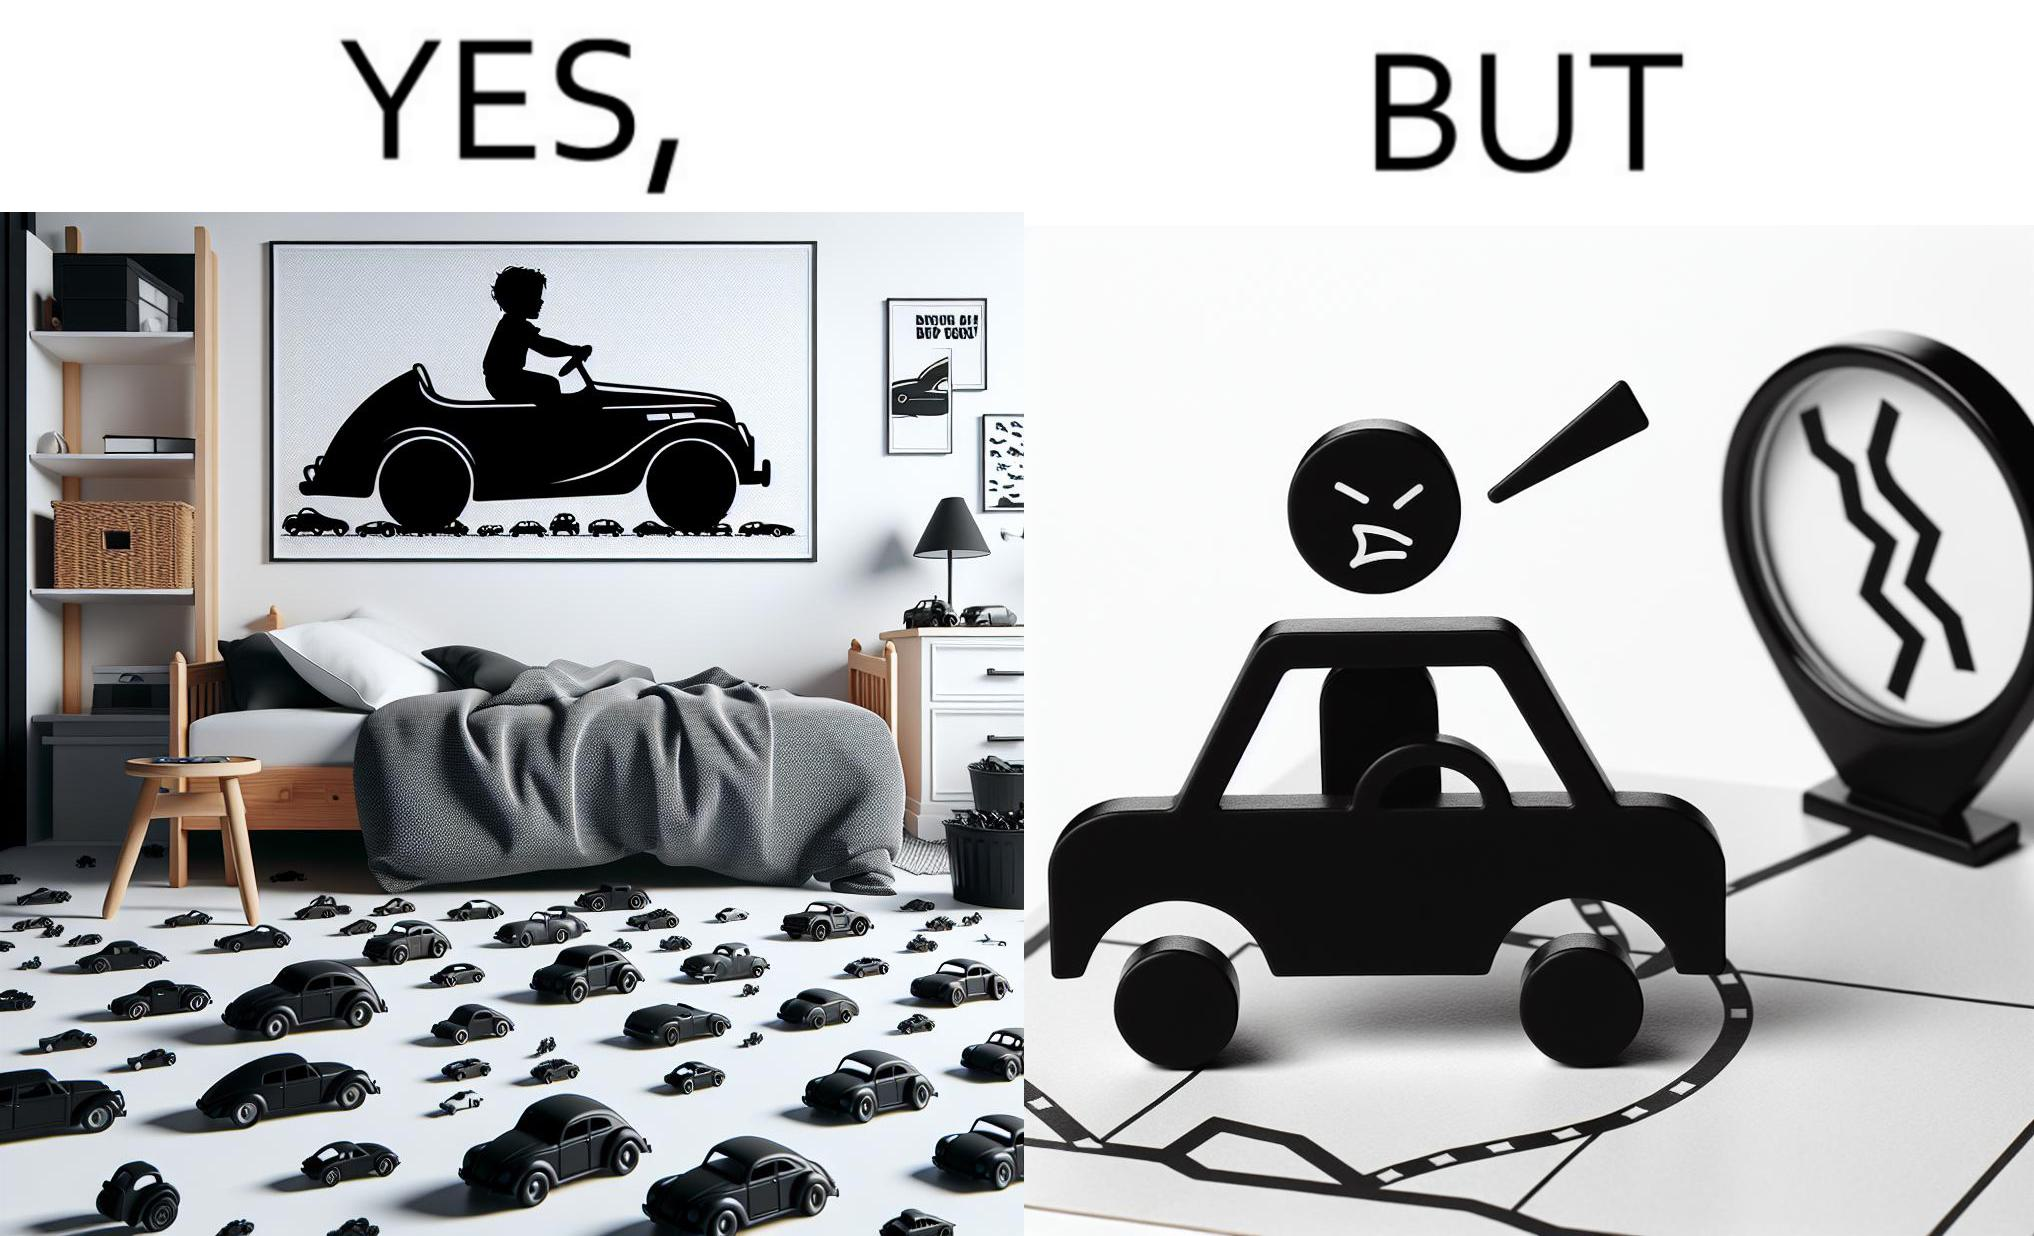What is shown in the left half versus the right half of this image? In the left part of the image: The image shows the bedroom of a child with various small toy cars and posters of cars on the wall. The child in the picture is also riding a bigger toy car. In the right part of the image: The image shows a man annoyed by the slow traffic on his way as shown on the map while he is driving. 